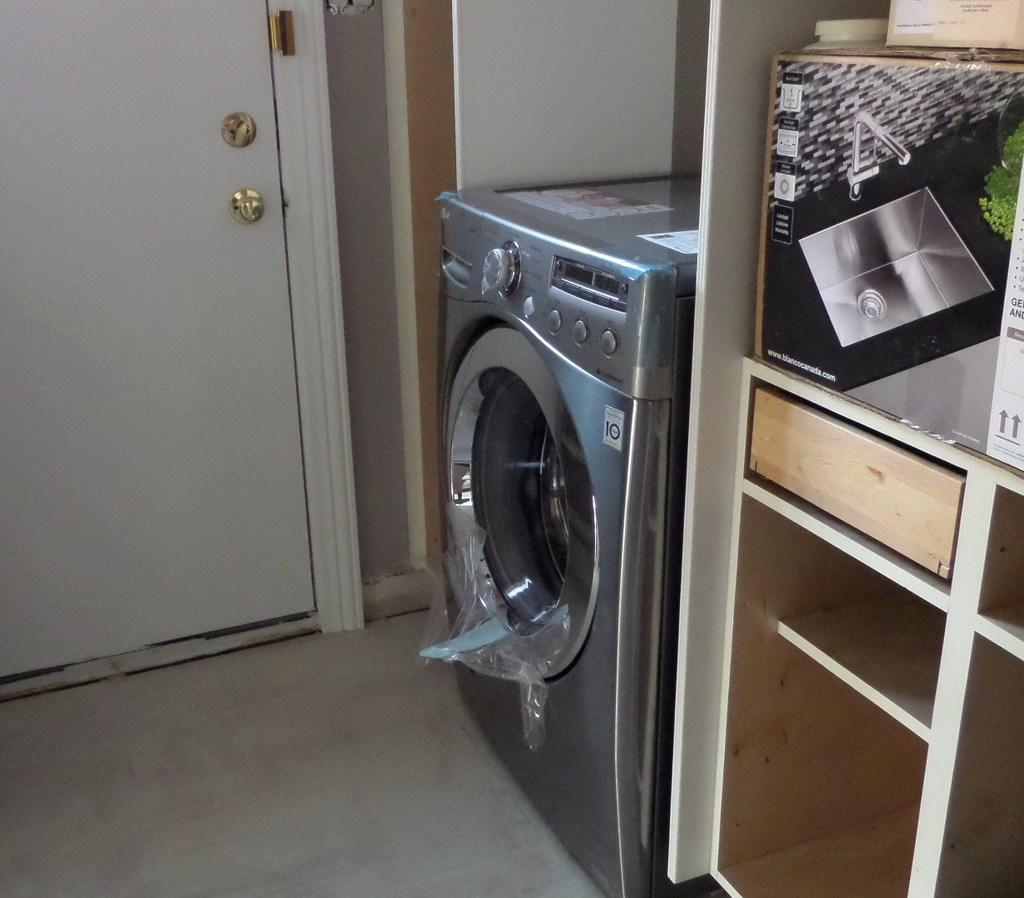What appliance can be seen in the image? There is a washing machine in the image. What else is present on a raised surface in the image? There is a box on a cupboard in the image. What can be observed on the box? The box has images and text on it. Can you identify any architectural features in the image? There is a door visible in the image. What is the price of the washing machine in the image? The price of the washing machine is not visible in the image, so it cannot be determined. 